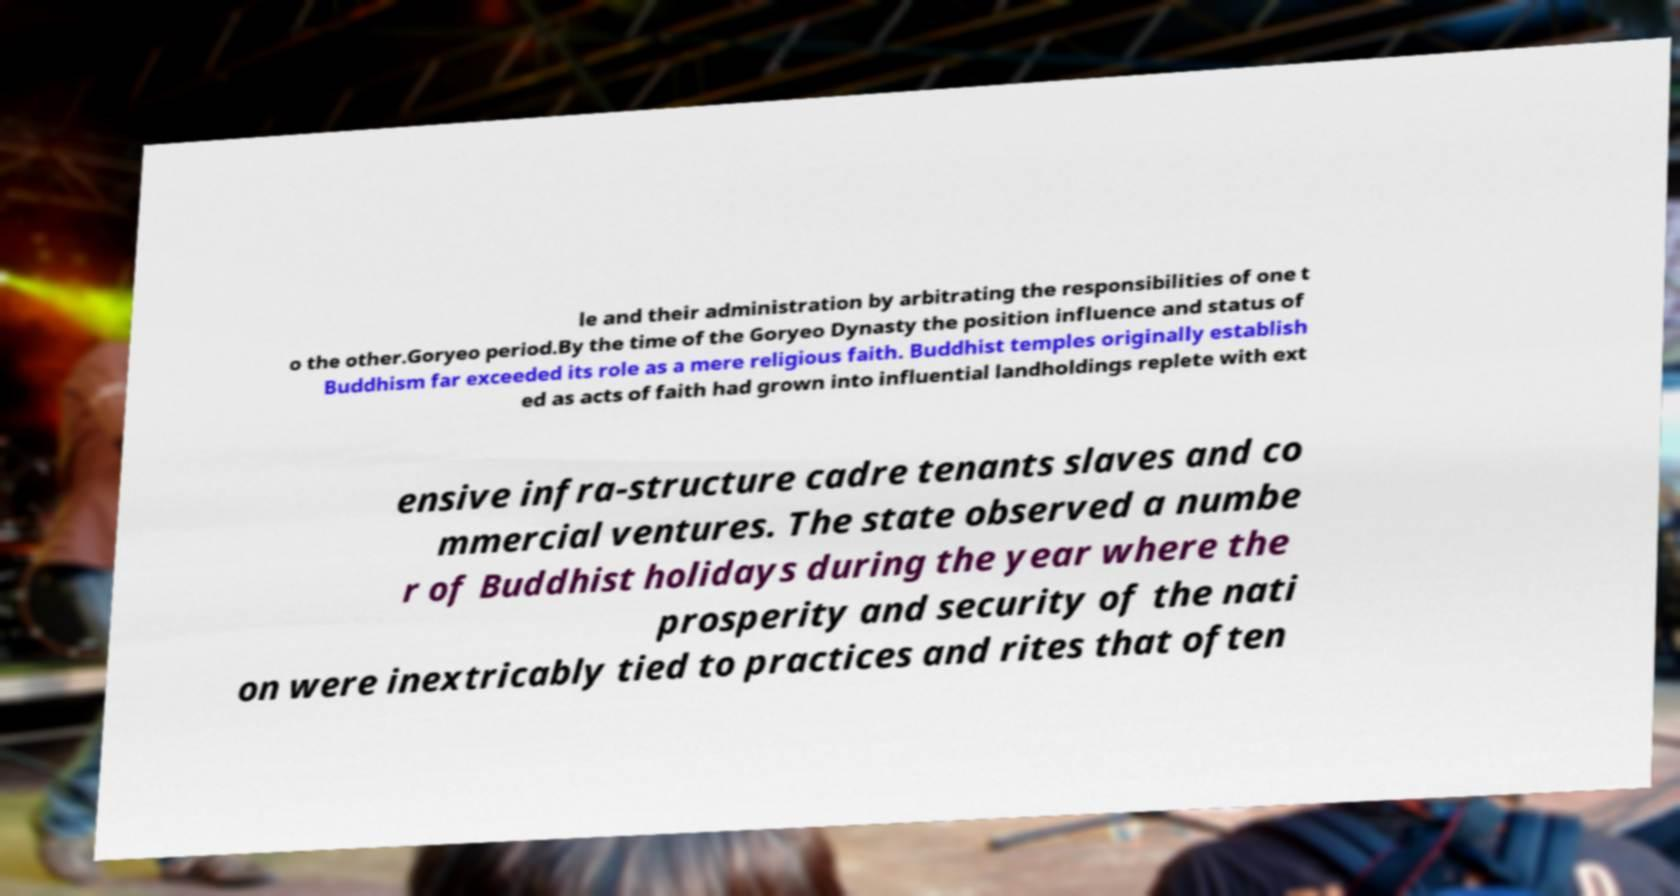Can you read and provide the text displayed in the image?This photo seems to have some interesting text. Can you extract and type it out for me? le and their administration by arbitrating the responsibilities of one t o the other.Goryeo period.By the time of the Goryeo Dynasty the position influence and status of Buddhism far exceeded its role as a mere religious faith. Buddhist temples originally establish ed as acts of faith had grown into influential landholdings replete with ext ensive infra-structure cadre tenants slaves and co mmercial ventures. The state observed a numbe r of Buddhist holidays during the year where the prosperity and security of the nati on were inextricably tied to practices and rites that often 